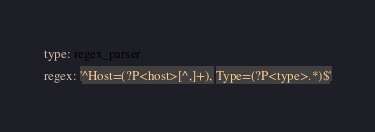Convert code to text. <code><loc_0><loc_0><loc_500><loc_500><_YAML_>type: regex_parser
regex: '^Host=(?P<host>[^,]+), Type=(?P<type>.*)$'
</code> 